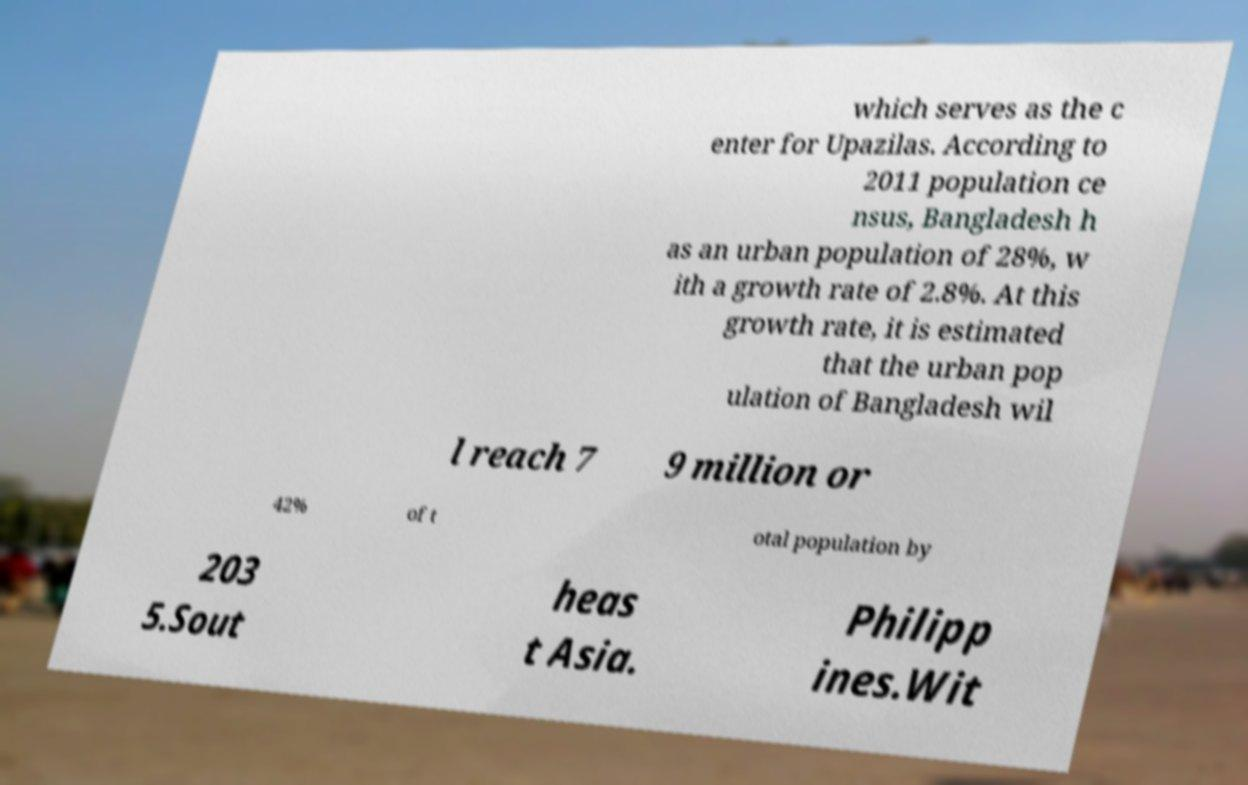Can you accurately transcribe the text from the provided image for me? which serves as the c enter for Upazilas. According to 2011 population ce nsus, Bangladesh h as an urban population of 28%, w ith a growth rate of 2.8%. At this growth rate, it is estimated that the urban pop ulation of Bangladesh wil l reach 7 9 million or 42% of t otal population by 203 5.Sout heas t Asia. Philipp ines.Wit 